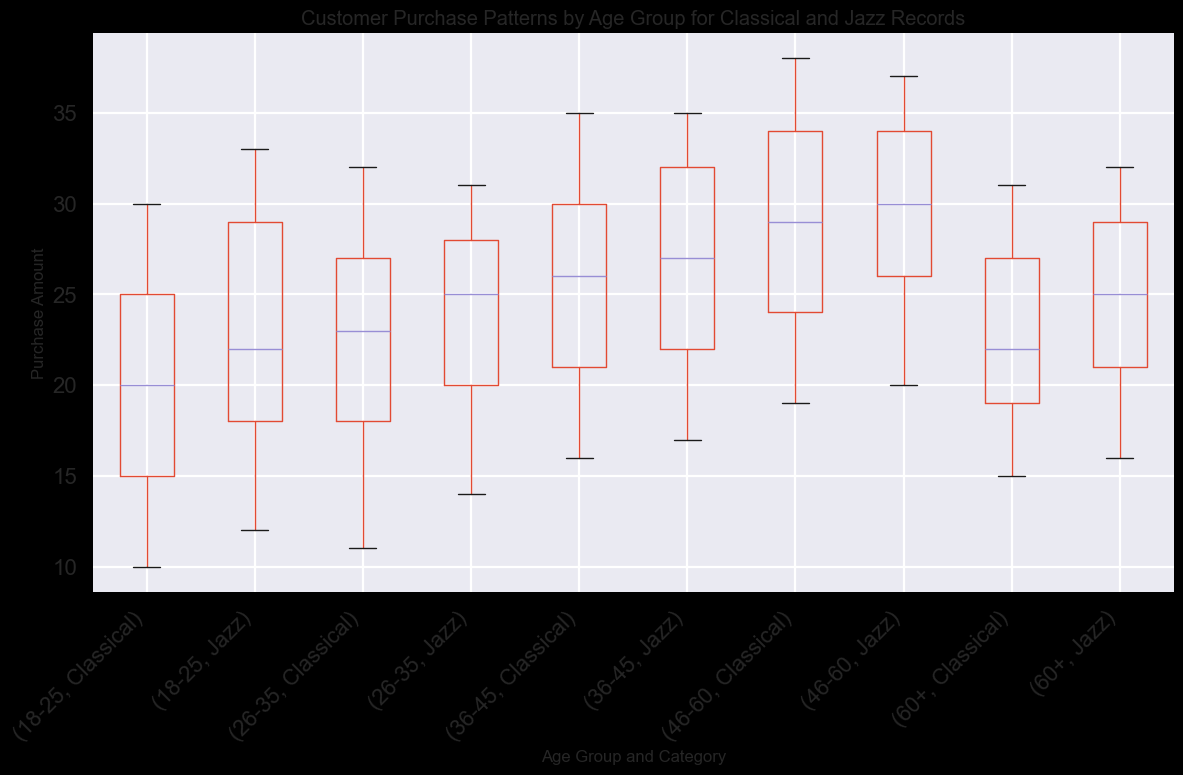Which age group has the highest median purchase amount for Classical records? To identify the median, look at the central line in the box for each age group within the Classical category. The 46-60 age group has the highest median line compared to other age groups.
Answer: 46-60 Which age group has the largest range in purchase amounts for Jazz records? The range is the difference between the maximum and minimum values, represented by the ends of the whiskers. The 18-25 age group in the Jazz category shows the largest visual spread between the whiskers.
Answer: 18-25 What is the median purchase amount for customers aged 36-45 for Classical records? Locate the box for the 36-45 age group within the Classical category and identify the central line in that box. This represents the median.
Answer: 26 Which category—Classical or Jazz—has a higher median purchase amount for customers aged 26-35? Compare the central lines in the boxes for the age group 26-35 under both Classical and Jazz categories. The median line for Jazz is higher than that for Classical.
Answer: Jazz Between the age groups 18-25 and 60+, which has a higher maximum purchase amount for Classical records? Look at the whisker on the upper end for both the 18-25 and 60+ age groups in the Classical category. The 18-25 group has a higher whisker.
Answer: 18-25 For the age group 46-60, is the purchase amount variability higher for Classical or Jazz records? Variability can be assessed by the length of the box and whiskers. The length for the Classical category within the 46-60 age group is greater than that for Jazz.
Answer: Classical Across both Classical and Jazz categories, which age group has the smallest interquartile range (IQR) for purchase amounts? IQR is represented by the height of the box. The smallest box appears in the 60+ age group under the Classical category.
Answer: 60+ What is the 75th percentile purchase amount for the age group 26-35 in the Jazz category? The 75th percentile is the top of the box. For the 26-35 age group in the Jazz category, it corresponds to the top boundary of the box.
Answer: 31 Which age group shows the least overlap in purchase amounts between Classical and Jazz categories? Identify the boxes for each age group under both Classical and Jazz categories and compare their vertical positions. The 18-25 age group shows the most distinct separation with minimal overlap.
Answer: 18-25 What is the difference between the median purchase amounts of Classical records for age groups 46-60 and 60+? Find the central lines for the 46-60 and 60+ age groups in the Classical category and compute the difference. The medians are 29 and 22 respectively, so the difference is 29 - 22.
Answer: 7 